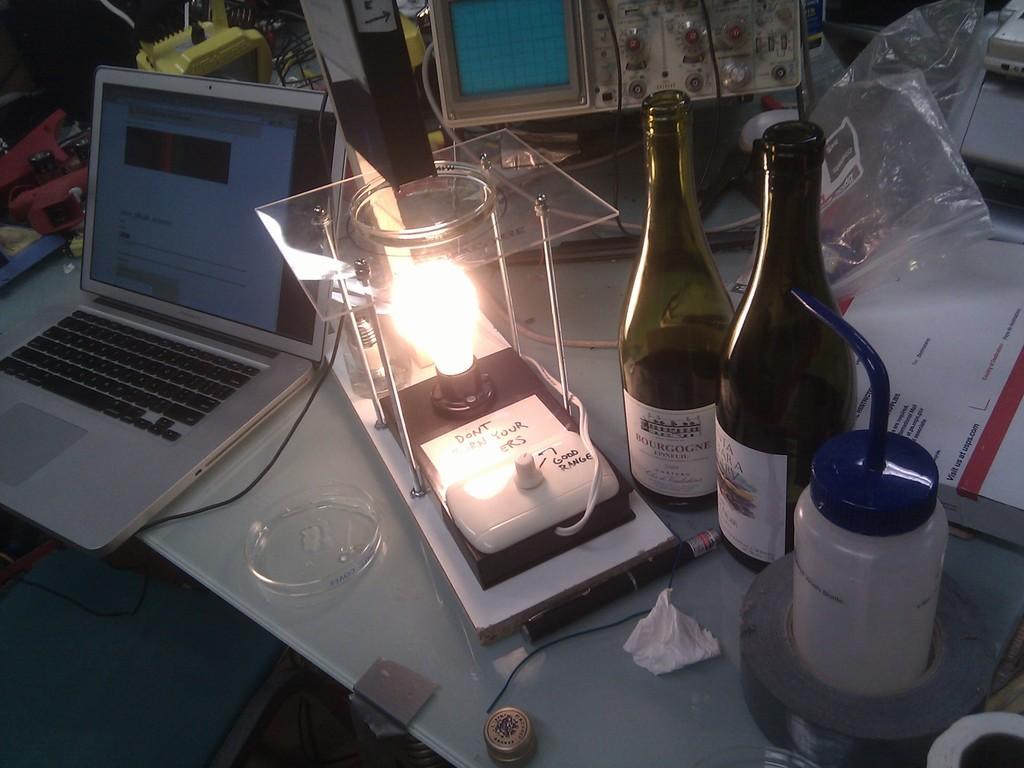Can you describe this image briefly? In this picture we can see table and on table we have laptop, machine, plastic cover, two bottles, bowl, pen, tape, bulb, glass flask. 